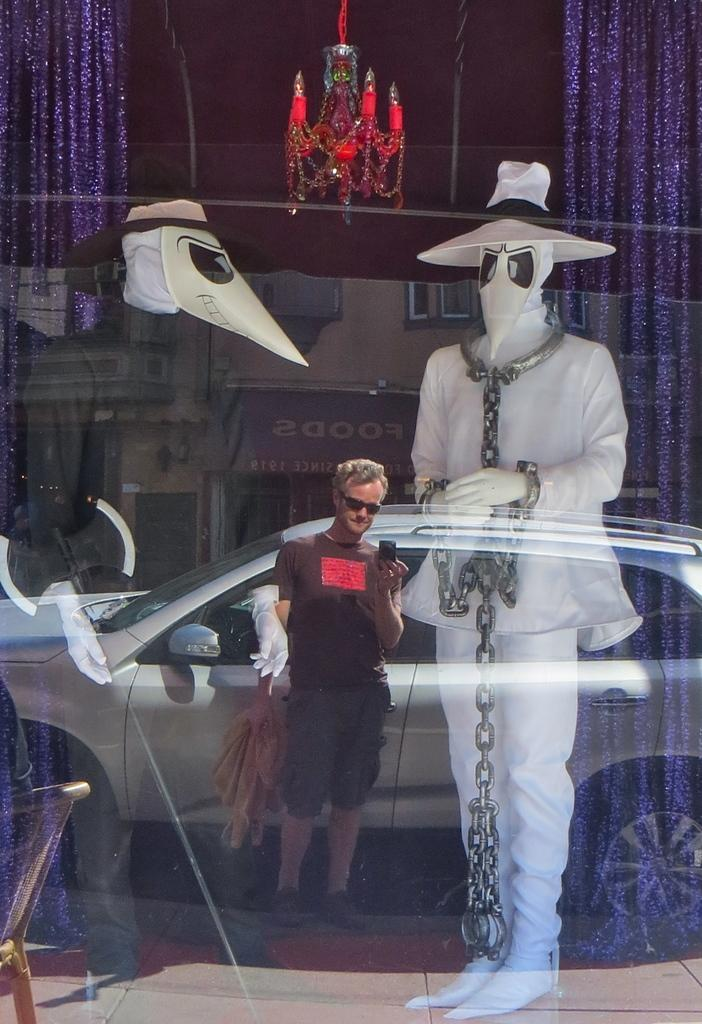What type of objects can be found in the store in the image? There are mannequins in the store in the image. What else can be seen in the image besides the store? There is a reflection of a man, a car, and a building in the image. How many kittens are playing with a coach in the image? There are no kittens or coaches present in the image. 